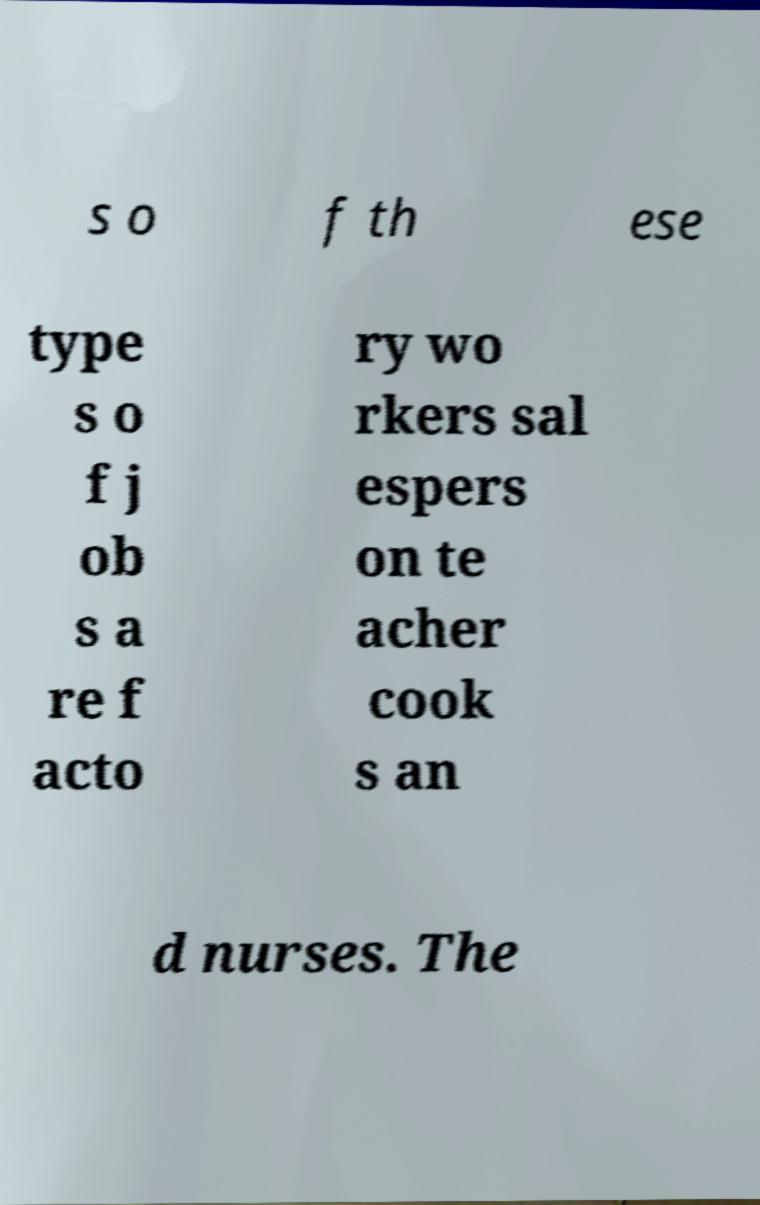Please read and relay the text visible in this image. What does it say? s o f th ese type s o f j ob s a re f acto ry wo rkers sal espers on te acher cook s an d nurses. The 